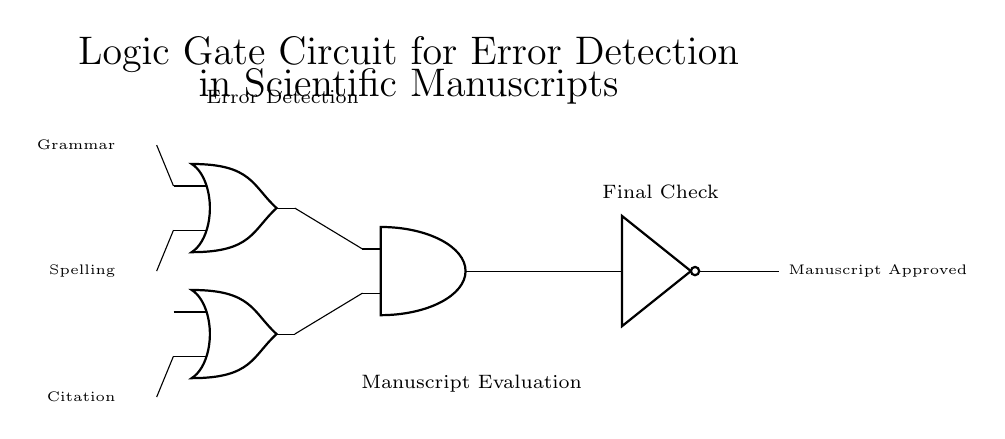What are the inputs to the circuit? The circuit has three inputs: Grammar, Spelling, and Citation, indicated by the labels on the left side.
Answer: Grammar, Spelling, Citation Which type of logic gate is used to combine the Grammar and Spelling inputs? The Grammar and Spelling inputs are combined using an OR gate, as shown at the position in the circuit diagram.
Answer: OR gate What is the output of the AND gate? The output of the AND gate provides the final check after evaluating the results of the OR gates. It is connected to the NOT gate, which inverts the signal. The output is indicated as "Manuscript Approved".
Answer: Manuscript Approved How many logic gates are present in this circuit diagram? The circuit contains four logic gates: two OR gates, one AND gate, and one NOT gate.
Answer: Four What does the NOT gate do in this circuit? The NOT gate inverts the output signal from the AND gate, effectively changing the approval status of the manuscript based on whether errors are detected or not.
Answer: Inverts signal What combination of inputs will result in a "Manuscript Approved" output? To achieve a "Manuscript Approved" output, both OR gates must produce a high output, implying at least one of Grammar or Spelling must be correct, and Citation cannot be the only factor.
Answer: At least one of Grammar or Spelling must be true, Citation false What does this circuit primarily detect? This circuit is designed to detect errors in a scientific manuscript based on the inputs provided, specifically grammar, spelling, and citations.
Answer: Errors in the manuscript 